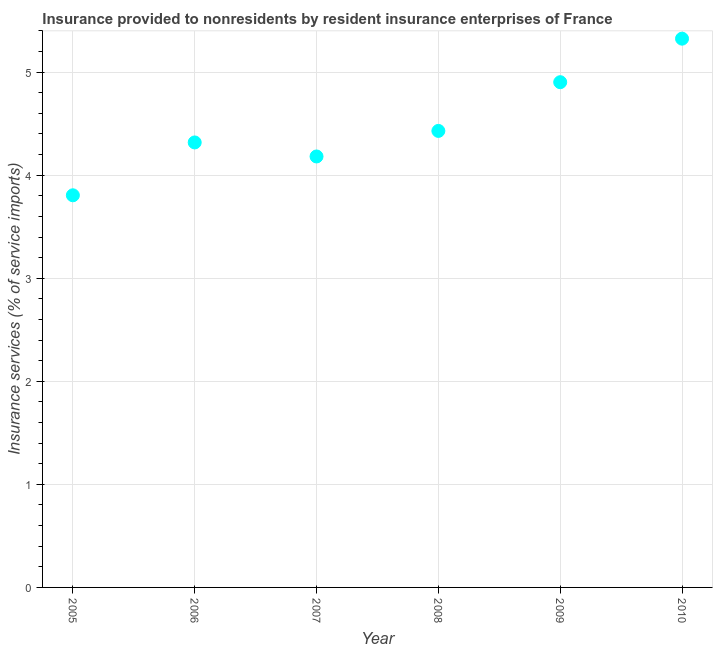What is the insurance and financial services in 2010?
Ensure brevity in your answer.  5.32. Across all years, what is the maximum insurance and financial services?
Provide a short and direct response. 5.32. Across all years, what is the minimum insurance and financial services?
Offer a very short reply. 3.81. What is the sum of the insurance and financial services?
Ensure brevity in your answer.  26.96. What is the difference between the insurance and financial services in 2006 and 2009?
Your answer should be very brief. -0.58. What is the average insurance and financial services per year?
Give a very brief answer. 4.49. What is the median insurance and financial services?
Give a very brief answer. 4.37. Do a majority of the years between 2007 and 2008 (inclusive) have insurance and financial services greater than 1 %?
Keep it short and to the point. Yes. What is the ratio of the insurance and financial services in 2006 to that in 2008?
Ensure brevity in your answer.  0.97. What is the difference between the highest and the second highest insurance and financial services?
Provide a succinct answer. 0.42. Is the sum of the insurance and financial services in 2005 and 2009 greater than the maximum insurance and financial services across all years?
Provide a short and direct response. Yes. What is the difference between the highest and the lowest insurance and financial services?
Give a very brief answer. 1.52. In how many years, is the insurance and financial services greater than the average insurance and financial services taken over all years?
Your answer should be very brief. 2. How many dotlines are there?
Make the answer very short. 1. What is the difference between two consecutive major ticks on the Y-axis?
Your answer should be very brief. 1. Are the values on the major ticks of Y-axis written in scientific E-notation?
Your answer should be compact. No. Does the graph contain grids?
Keep it short and to the point. Yes. What is the title of the graph?
Provide a succinct answer. Insurance provided to nonresidents by resident insurance enterprises of France. What is the label or title of the Y-axis?
Keep it short and to the point. Insurance services (% of service imports). What is the Insurance services (% of service imports) in 2005?
Your answer should be very brief. 3.81. What is the Insurance services (% of service imports) in 2006?
Provide a short and direct response. 4.32. What is the Insurance services (% of service imports) in 2007?
Ensure brevity in your answer.  4.18. What is the Insurance services (% of service imports) in 2008?
Ensure brevity in your answer.  4.43. What is the Insurance services (% of service imports) in 2009?
Provide a succinct answer. 4.9. What is the Insurance services (% of service imports) in 2010?
Offer a very short reply. 5.32. What is the difference between the Insurance services (% of service imports) in 2005 and 2006?
Ensure brevity in your answer.  -0.51. What is the difference between the Insurance services (% of service imports) in 2005 and 2007?
Provide a short and direct response. -0.38. What is the difference between the Insurance services (% of service imports) in 2005 and 2008?
Your response must be concise. -0.62. What is the difference between the Insurance services (% of service imports) in 2005 and 2009?
Your response must be concise. -1.1. What is the difference between the Insurance services (% of service imports) in 2005 and 2010?
Keep it short and to the point. -1.52. What is the difference between the Insurance services (% of service imports) in 2006 and 2007?
Keep it short and to the point. 0.14. What is the difference between the Insurance services (% of service imports) in 2006 and 2008?
Offer a terse response. -0.11. What is the difference between the Insurance services (% of service imports) in 2006 and 2009?
Your answer should be very brief. -0.58. What is the difference between the Insurance services (% of service imports) in 2006 and 2010?
Your answer should be compact. -1.01. What is the difference between the Insurance services (% of service imports) in 2007 and 2008?
Your response must be concise. -0.25. What is the difference between the Insurance services (% of service imports) in 2007 and 2009?
Your answer should be very brief. -0.72. What is the difference between the Insurance services (% of service imports) in 2007 and 2010?
Keep it short and to the point. -1.14. What is the difference between the Insurance services (% of service imports) in 2008 and 2009?
Give a very brief answer. -0.47. What is the difference between the Insurance services (% of service imports) in 2008 and 2010?
Make the answer very short. -0.9. What is the difference between the Insurance services (% of service imports) in 2009 and 2010?
Make the answer very short. -0.42. What is the ratio of the Insurance services (% of service imports) in 2005 to that in 2006?
Offer a terse response. 0.88. What is the ratio of the Insurance services (% of service imports) in 2005 to that in 2007?
Your answer should be very brief. 0.91. What is the ratio of the Insurance services (% of service imports) in 2005 to that in 2008?
Offer a terse response. 0.86. What is the ratio of the Insurance services (% of service imports) in 2005 to that in 2009?
Offer a terse response. 0.78. What is the ratio of the Insurance services (% of service imports) in 2005 to that in 2010?
Provide a succinct answer. 0.71. What is the ratio of the Insurance services (% of service imports) in 2006 to that in 2007?
Ensure brevity in your answer.  1.03. What is the ratio of the Insurance services (% of service imports) in 2006 to that in 2008?
Ensure brevity in your answer.  0.97. What is the ratio of the Insurance services (% of service imports) in 2006 to that in 2009?
Make the answer very short. 0.88. What is the ratio of the Insurance services (% of service imports) in 2006 to that in 2010?
Offer a very short reply. 0.81. What is the ratio of the Insurance services (% of service imports) in 2007 to that in 2008?
Ensure brevity in your answer.  0.94. What is the ratio of the Insurance services (% of service imports) in 2007 to that in 2009?
Your answer should be compact. 0.85. What is the ratio of the Insurance services (% of service imports) in 2007 to that in 2010?
Keep it short and to the point. 0.79. What is the ratio of the Insurance services (% of service imports) in 2008 to that in 2009?
Offer a very short reply. 0.9. What is the ratio of the Insurance services (% of service imports) in 2008 to that in 2010?
Keep it short and to the point. 0.83. What is the ratio of the Insurance services (% of service imports) in 2009 to that in 2010?
Provide a succinct answer. 0.92. 